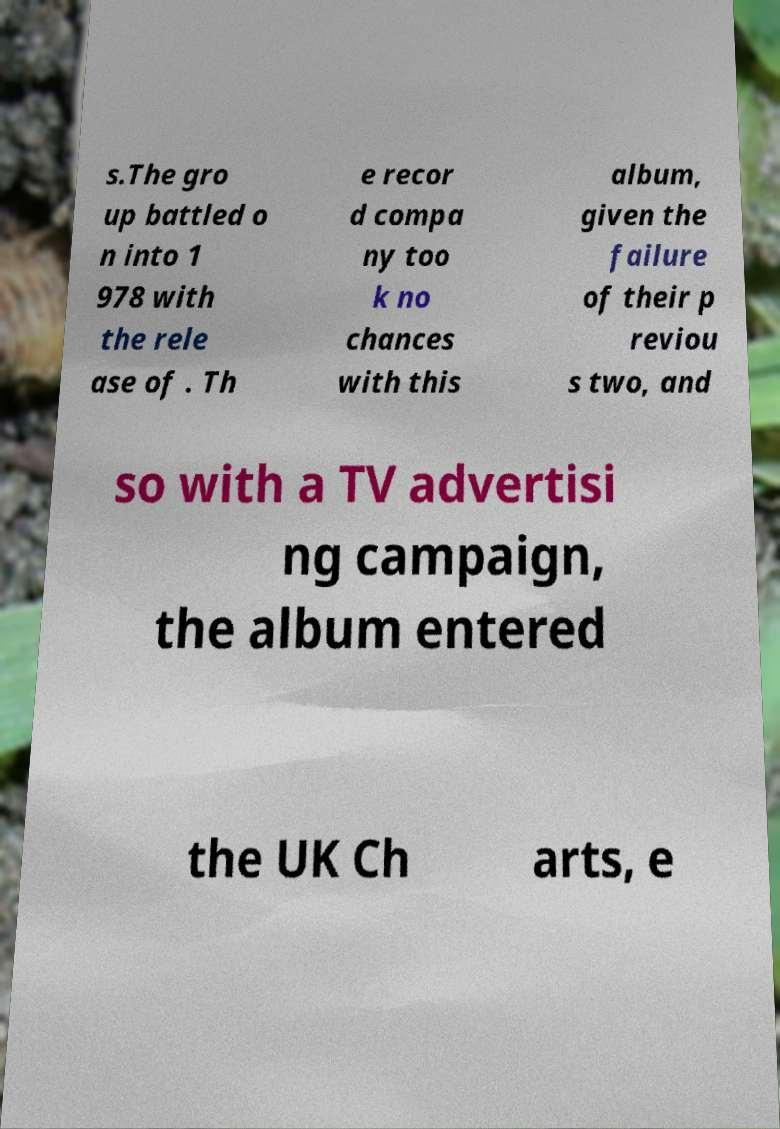Could you assist in decoding the text presented in this image and type it out clearly? s.The gro up battled o n into 1 978 with the rele ase of . Th e recor d compa ny too k no chances with this album, given the failure of their p reviou s two, and so with a TV advertisi ng campaign, the album entered the UK Ch arts, e 